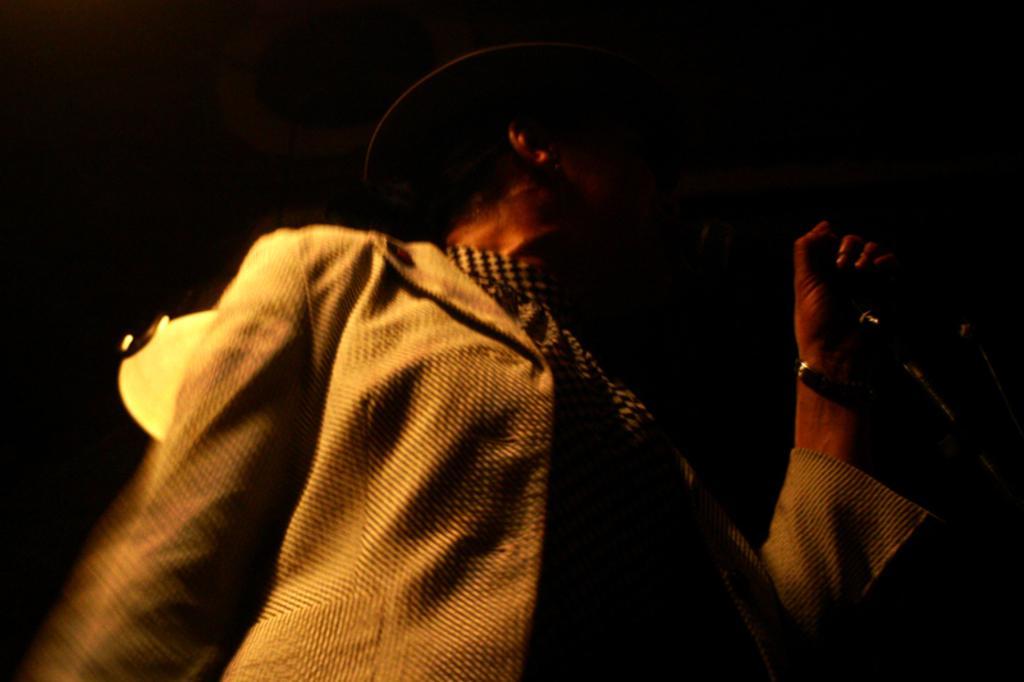Could you give a brief overview of what you see in this image? This picture is completely dark. In this picture a man is standing and i guess he is singing something. This is the mike , he is wearing a brown colour with black lined blazer. Behind the man there is a light. 